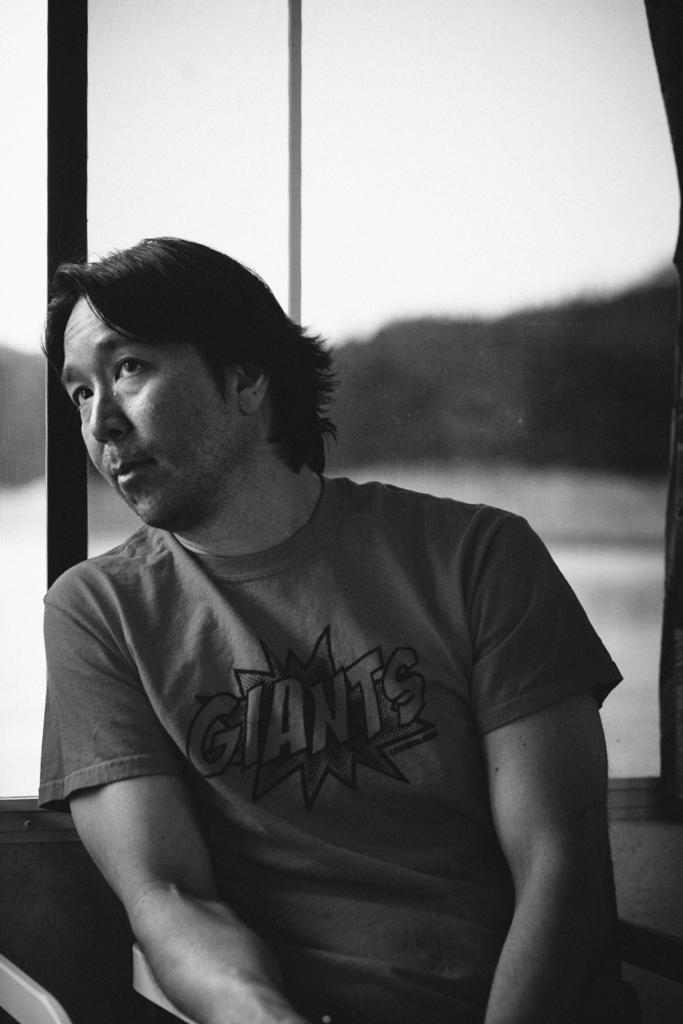What is the color scheme of the image? The image is black and white. Can you describe the person in the image? There is a man in the image. What is the man wearing? The man is wearing a t-shirt. Is there any text visible in the image? There is a word written in the image, but it is blurred in the background. What type of laborer is depicted in the image? There is no laborer present in the image; it features a man wearing a t-shirt. How many steps can be seen in the image? There are no steps visible in the image. 